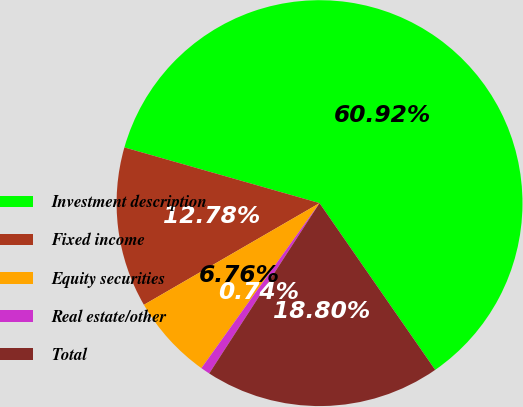Convert chart. <chart><loc_0><loc_0><loc_500><loc_500><pie_chart><fcel>Investment description<fcel>Fixed income<fcel>Equity securities<fcel>Real estate/other<fcel>Total<nl><fcel>60.93%<fcel>12.78%<fcel>6.76%<fcel>0.74%<fcel>18.8%<nl></chart> 